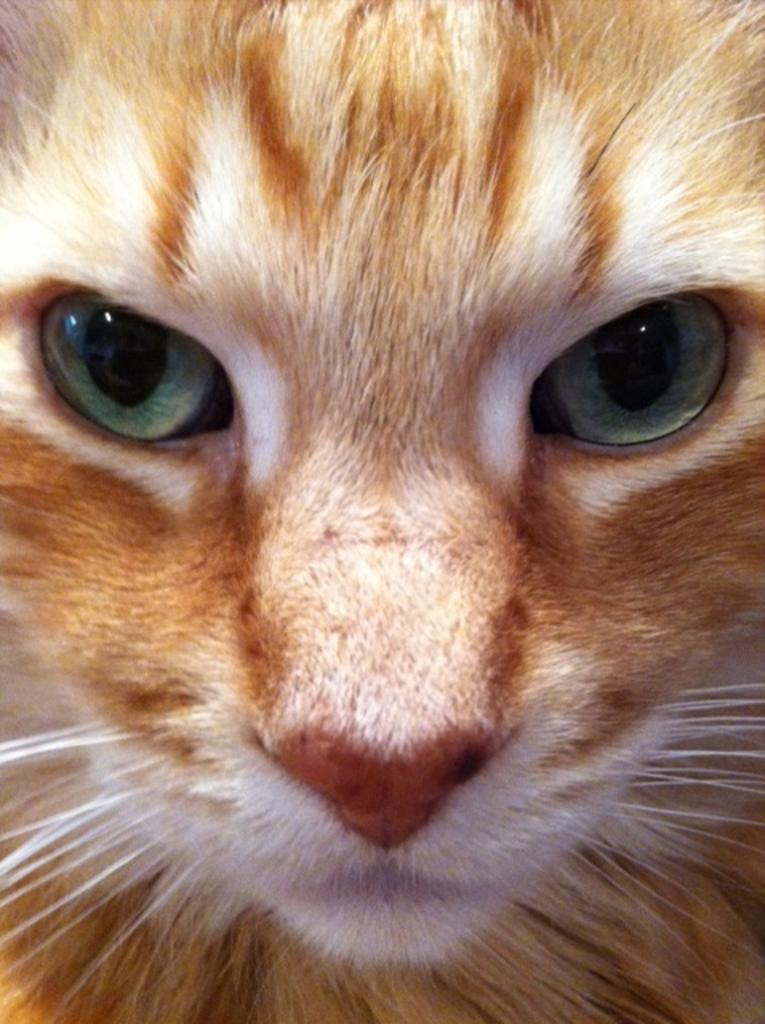What type of animal is in the image? There is a cat in the image. What color is the zebra in the image? There is no zebra present in the image; it features a cat. How does the jellyfish feel in the image? There is no jellyfish present in the image, so it is not possible to determine how it might feel. 